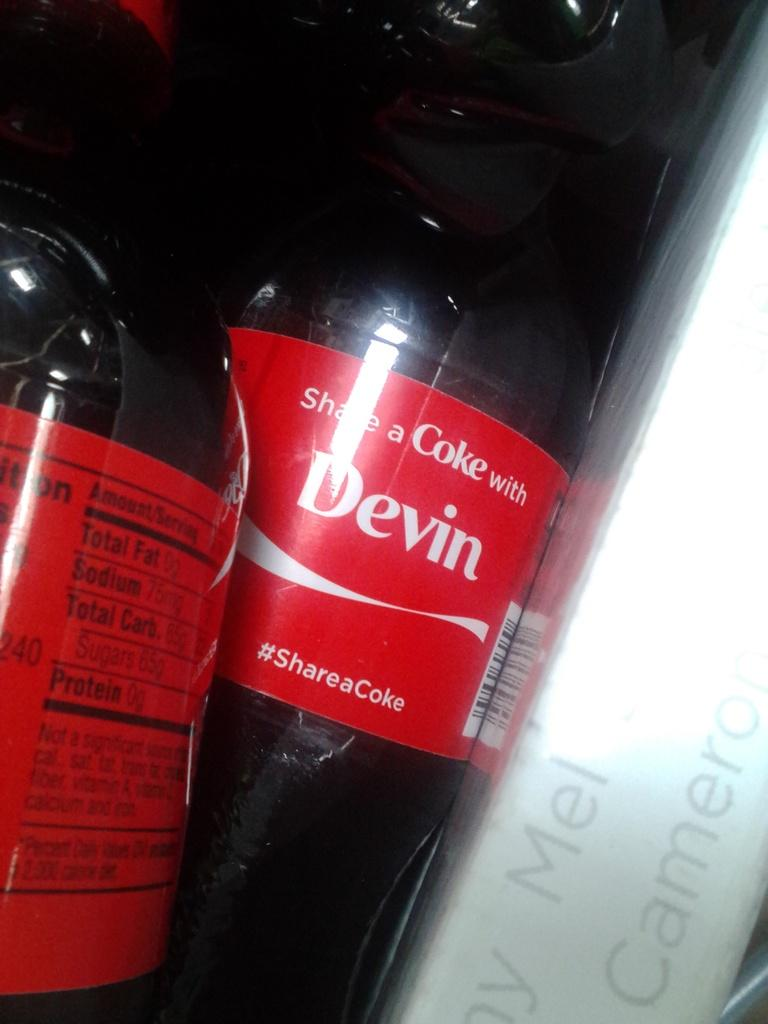What is present in the image that can be consumed? There is a drink in the image that can be consumed. What is the primary component of the drink? The drink has liquid in it. Is there any information or branding on the drink? Yes, the drink has a label on it. What type of lace can be seen on the rim of the glass in the image? There is no lace present on the rim of the glass in the image. Can you describe the ocean view from the plantation in the image? There is no ocean or plantation present in the image; it only features a drink with a label. 